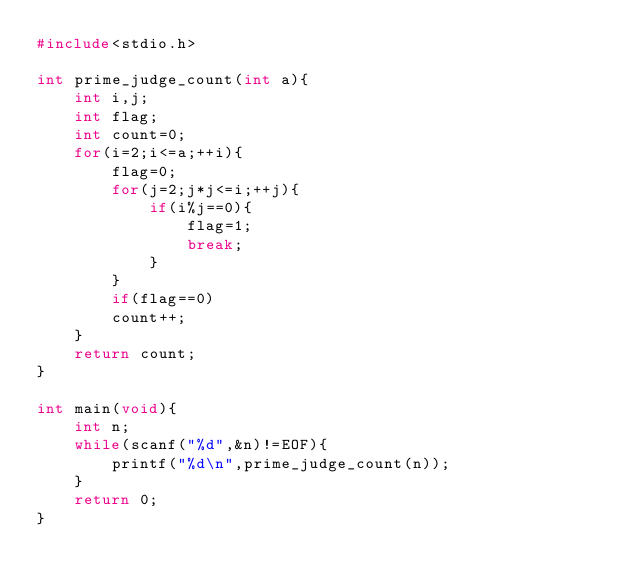<code> <loc_0><loc_0><loc_500><loc_500><_C_>#include<stdio.h>

int prime_judge_count(int a){
	int i,j;
	int flag;
	int count=0;
	for(i=2;i<=a;++i){
		flag=0;
		for(j=2;j*j<=i;++j){
			if(i%j==0){
				flag=1;
				break;
			}
		}
		if(flag==0)
		count++;
	}
	return count;
}

int main(void){
	int n;
	while(scanf("%d",&n)!=EOF){
		printf("%d\n",prime_judge_count(n));
	}
	return 0;
}</code> 